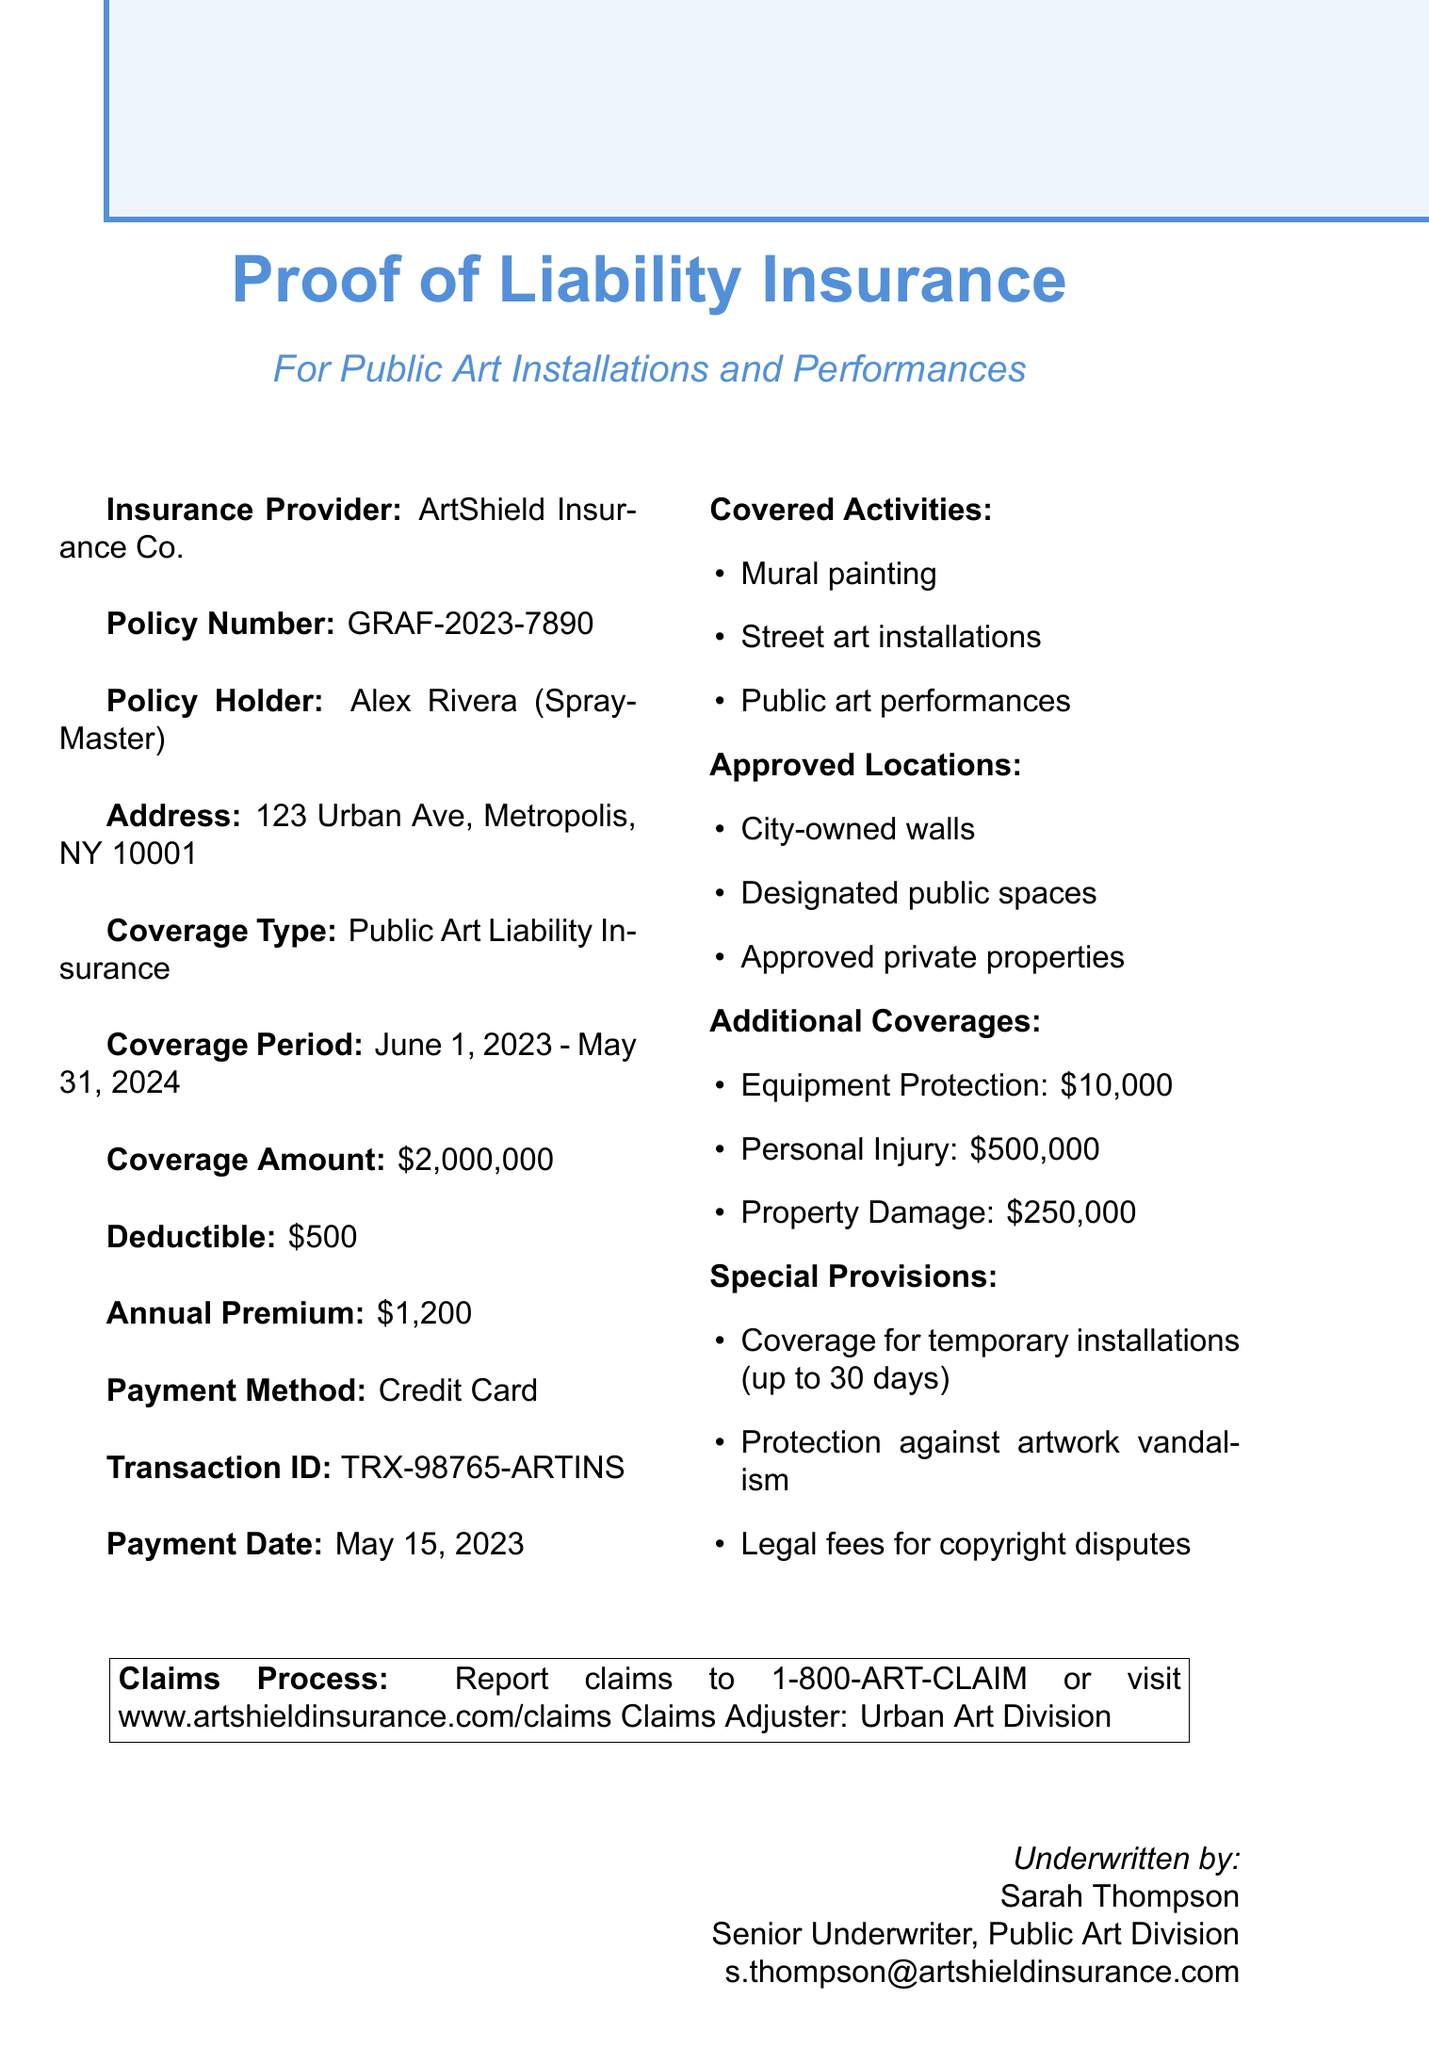What is the name of the insurance provider? The insurance provider is mentioned in the document as ArtShield Insurance Co.
Answer: ArtShield Insurance Co What is the coverage amount for this insurance policy? The coverage amount specified in the document is $2,000,000.
Answer: $2,000,000 What is the deductible for the policy? The deductible stated in the document is $500.
Answer: $500 What is the annual premium amount? The document indicates that the annual premium is $1,200.
Answer: $1,200 Who is the policy holder? The document specifies the name of the policy holder as Alex Rivera, also known as SprayMaster.
Answer: Alex Rivera What type of insurance is this document referring to? The type of insurance coverage referred to in the document is Public Art Liability Insurance.
Answer: Public Art Liability Insurance How long does the coverage period last? The coverage period is from June 1, 2023, to May 31, 2024, which is one year.
Answer: One year What activities are covered by this insurance? The covered activities are mural painting, street art installations, and public art performances as listed in the document.
Answer: Mural painting, street art installations, public art performances What is the claims reporting hotline? The document provides the claims reporting hotline as 1-800-ART-CLAIM.
Answer: 1-800-ART-CLAIM What is the contact email for the underwriter? The underwriter's contact email provided in the document is s.thompson@artshieldinsurance.com.
Answer: s.thompson@artshieldinsurance.com 